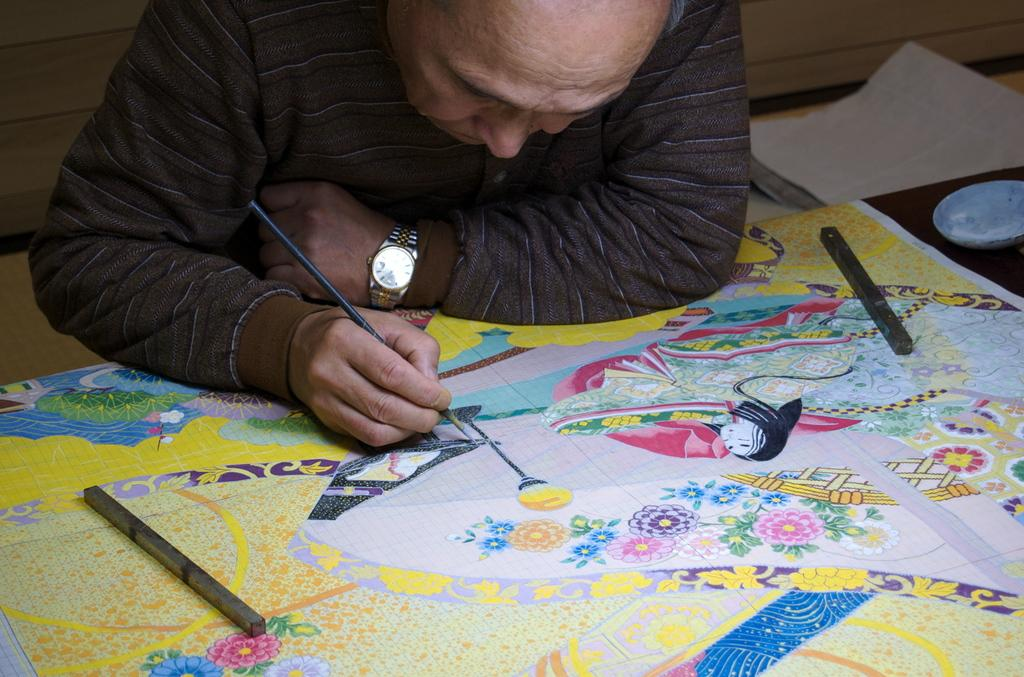What is the man in the image doing? The man is drawing a picture. What is the man drawing on? The man is drawing on a sheet. What type of pie is the man eating while drawing in the image? There is no pie present in the image; the man is drawing on a sheet. Is there a girl helping the man draw the picture in the image? There is no girl present in the image; the man is drawing by himself. 